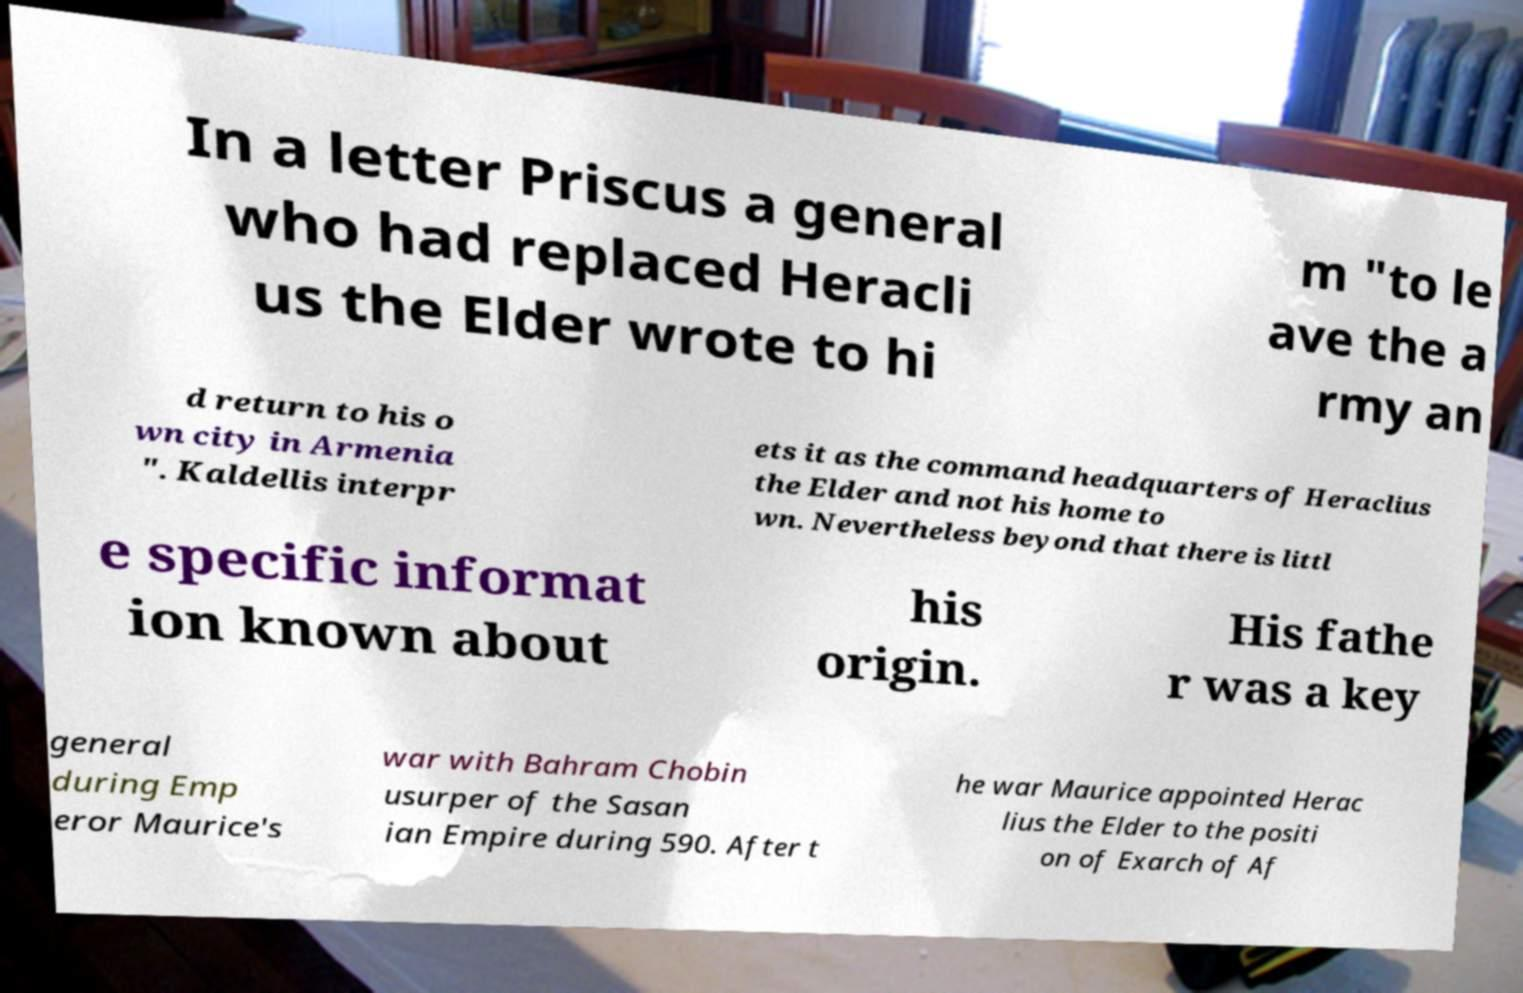Please identify and transcribe the text found in this image. In a letter Priscus a general who had replaced Heracli us the Elder wrote to hi m "to le ave the a rmy an d return to his o wn city in Armenia ". Kaldellis interpr ets it as the command headquarters of Heraclius the Elder and not his home to wn. Nevertheless beyond that there is littl e specific informat ion known about his origin. His fathe r was a key general during Emp eror Maurice's war with Bahram Chobin usurper of the Sasan ian Empire during 590. After t he war Maurice appointed Herac lius the Elder to the positi on of Exarch of Af 